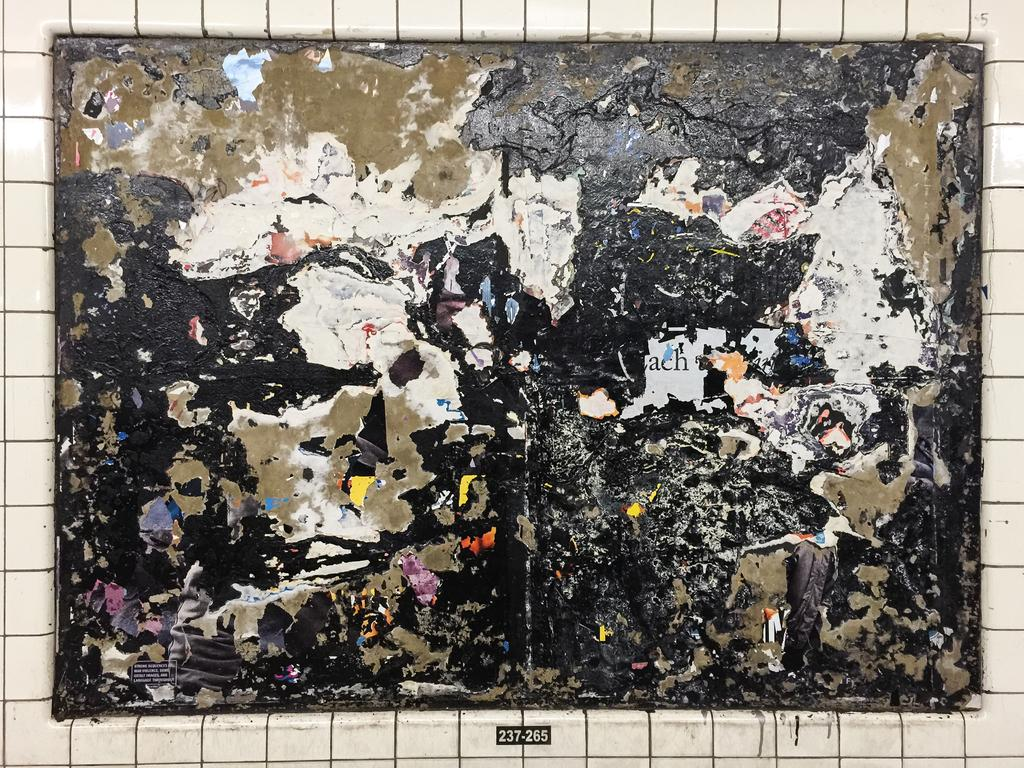Provide a one-sentence caption for the provided image. a very old ragged poster is on the wall and labeled 237-265. 